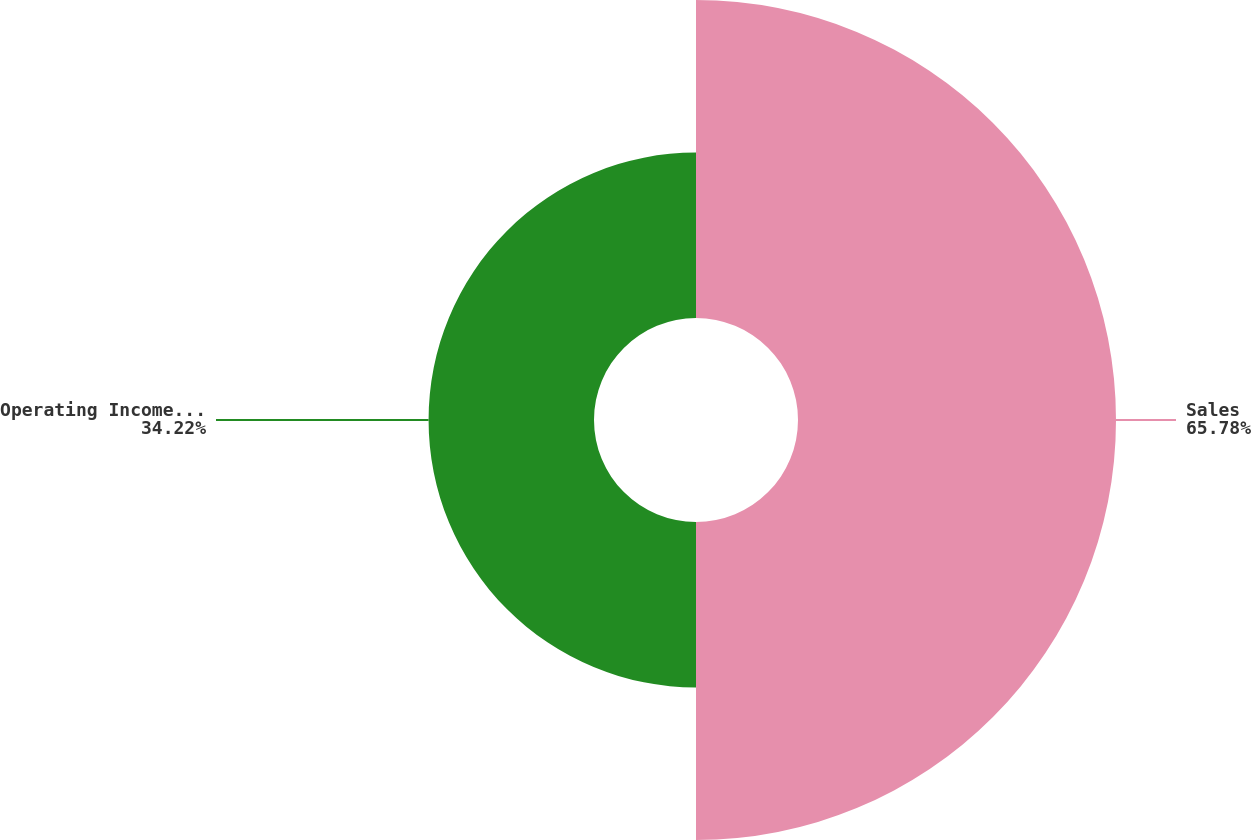Convert chart to OTSL. <chart><loc_0><loc_0><loc_500><loc_500><pie_chart><fcel>Sales<fcel>Operating Income (Loss)<nl><fcel>65.78%<fcel>34.22%<nl></chart> 